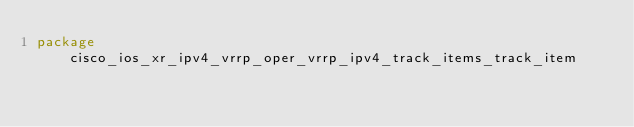<code> <loc_0><loc_0><loc_500><loc_500><_Go_>package cisco_ios_xr_ipv4_vrrp_oper_vrrp_ipv4_track_items_track_item
            
</code> 